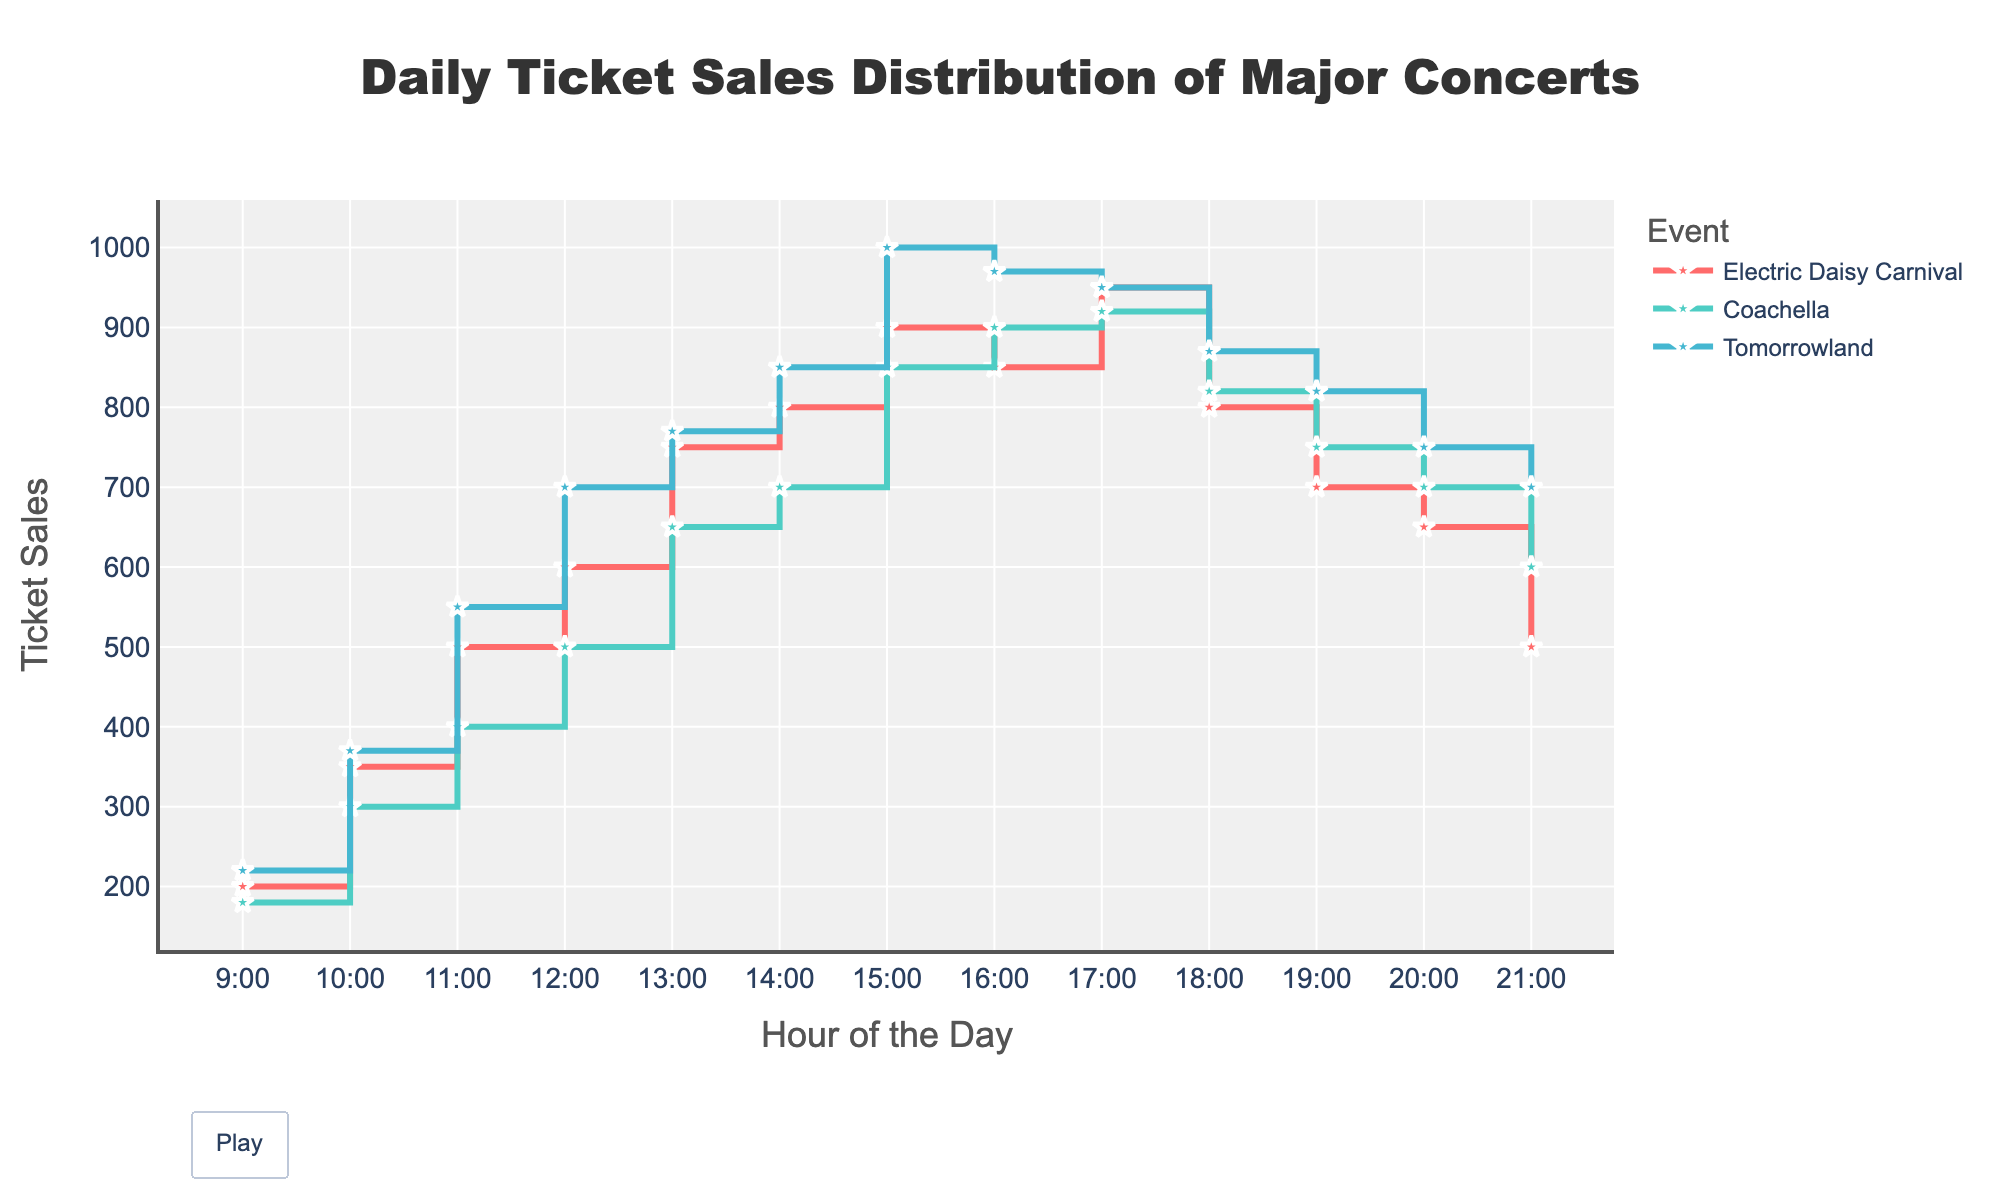What is the title of the plot? The title is displayed prominently at the top of the plot in large, bold font. It provides a summary of what the plot is depicting.
Answer: Daily Ticket Sales Distribution of Major Concerts Which event has the highest ticket sales at 15:00? To find the highest ticket sales at 15:00, look at the y-values (ticket sales) for each event at the 15:00 mark on the x-axis. The event with the highest point is Tomorrowland.
Answer: Tomorrowland At what hour does Electric Daisy Carnival reach its peak sales, and what is the value? Look for the highest point on the Electric Daisy Carnival line (marked by its distinct color and star markers). The peak occurs at 17:00 with ticket sales of 950.
Answer: 17:00, 950 What are the ticket sales for Coachella at 12:00 and 21:00? Find the points corresponding to Coachella at 12:00 and 21:00 on the x-axis, and read the y-values. They are 500 and 600, respectively.
Answer: 500, 600 How do the ticket sales for Tomorrowland at 18:00 compare to those at 20:00? Observe the y-values for Tomorrowland at 18:00 and 20:00. The sales are higher at 18:00 (870) than at 20:00 (750).
Answer: Higher at 18:00 What is the average ticket sales for Electric Daisy Carnival between 10:00 to 14:00? Sum the ticket sales for Electric Daisy Carnival from 10:00 (350) to 14:00 (800) and divide by the number of hours (5). The sum is 350 + 500 + 600 + 750 + 800 = 3000. Average: 3000 / 5 = 600.
Answer: 600 Which event shows the most consistent ticket sales over time? Examine the fluctuation of lines for each event. The event with the least variation in y-values over time is Electric Daisy Carnival.
Answer: Electric Daisy Carnival What hour has the lowest sales for Coachella and what is the value? Identify the lowest point on the Coachella line, which occurs at 9:00 with ticket sales of 180.
Answer: 9:00, 180 For Tomorrowland, how do ticket sales change from 12:00 to 13:00? Compare the y-values at 12:00 and 13:00 for Tomorrowland. Sales increase from 700 to 770.
Answer: Increase by 70 